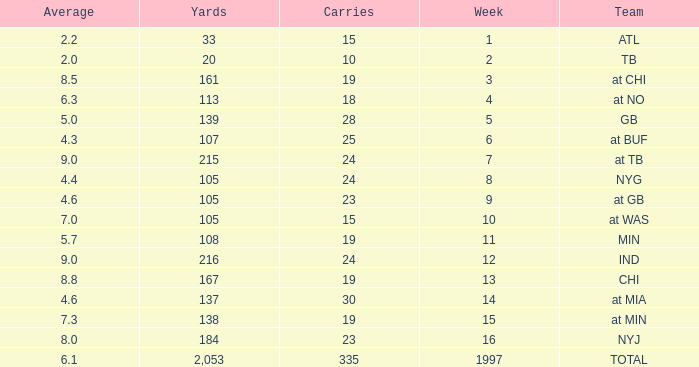Which average consists of yards exceeding 167, a team at tb, and a week greater than 7? None. 